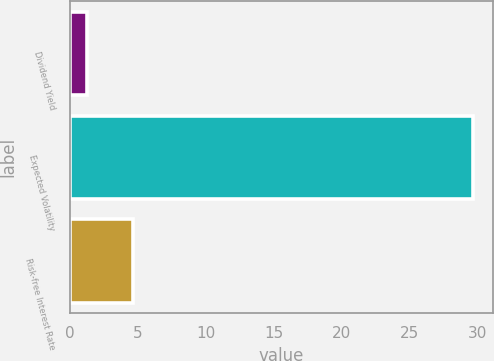<chart> <loc_0><loc_0><loc_500><loc_500><bar_chart><fcel>Dividend Yield<fcel>Expected Volatility<fcel>Risk-free Interest Rate<nl><fcel>1.27<fcel>29.65<fcel>4.7<nl></chart> 